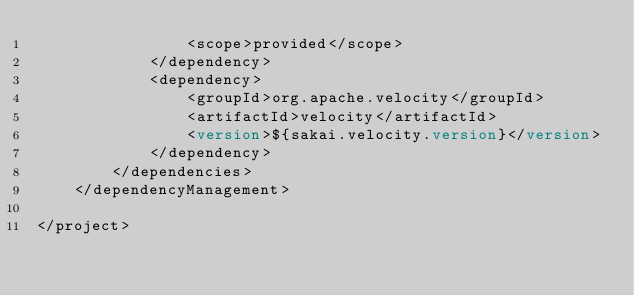Convert code to text. <code><loc_0><loc_0><loc_500><loc_500><_XML_>				<scope>provided</scope>
			</dependency>
			<dependency>
				<groupId>org.apache.velocity</groupId>
				<artifactId>velocity</artifactId>
				<version>${sakai.velocity.version}</version>
			</dependency>
		</dependencies>
	</dependencyManagement>

</project>
</code> 